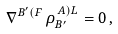<formula> <loc_0><loc_0><loc_500><loc_500>\nabla ^ { B ^ { \prime } ( F } \, \rho _ { B ^ { \prime } } ^ { \, A ) L } = 0 \, ,</formula> 